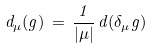<formula> <loc_0><loc_0><loc_500><loc_500>d _ { \mu } ( g ) \, = \, \frac { 1 } { | \mu | } \, d ( \delta _ { \mu } g )</formula> 